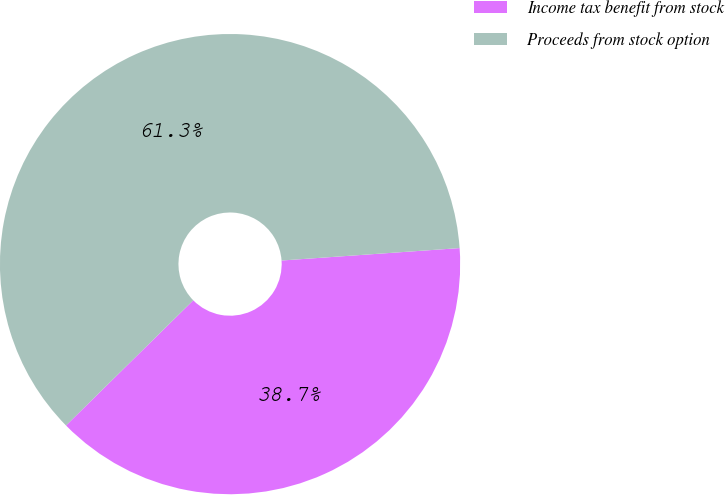Convert chart. <chart><loc_0><loc_0><loc_500><loc_500><pie_chart><fcel>Income tax benefit from stock<fcel>Proceeds from stock option<nl><fcel>38.74%<fcel>61.26%<nl></chart> 